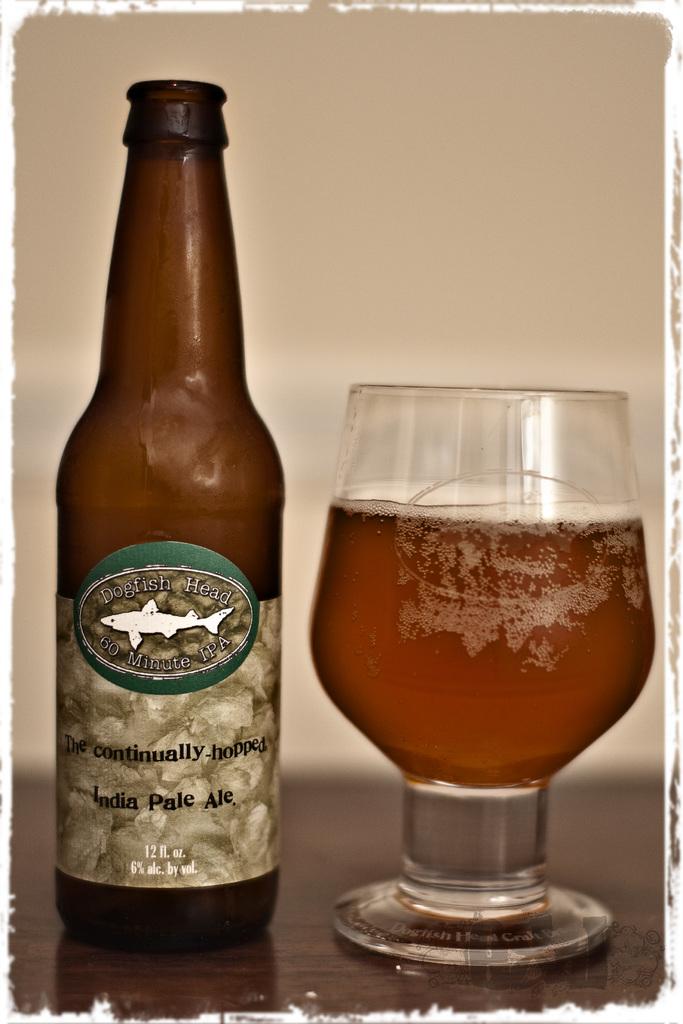What kind of drink is this?
Offer a terse response. India pale ale. How many ounces in this beer?
Your answer should be compact. 12. 